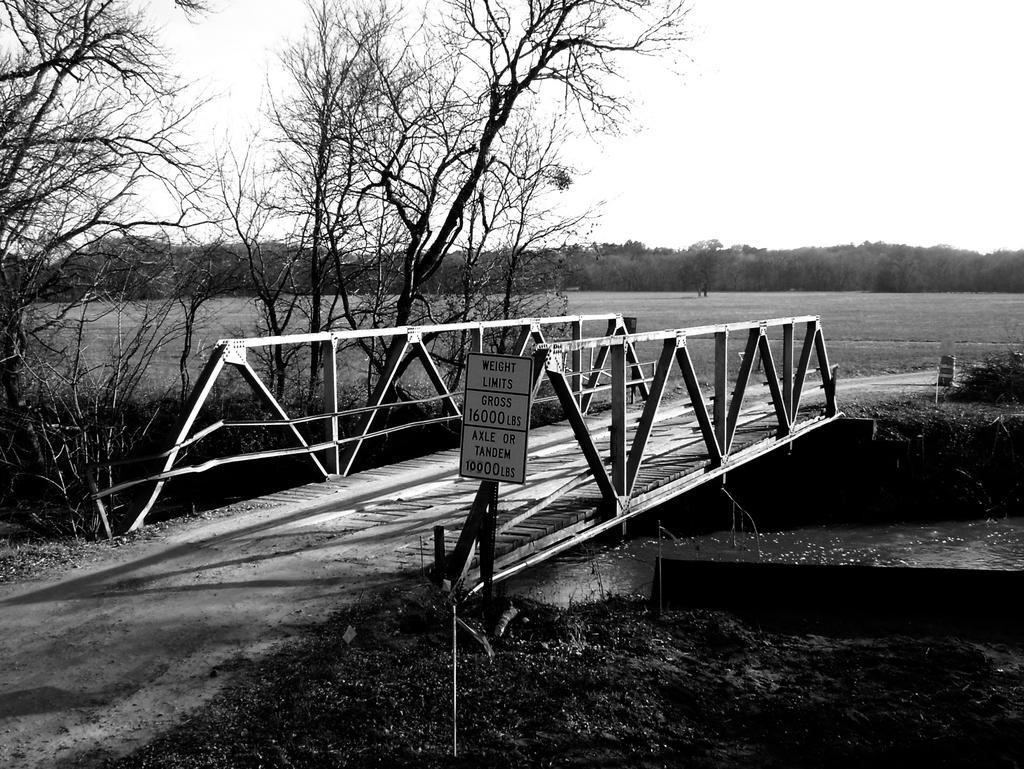How would you summarize this image in a sentence or two? In this picture I can see there is a wooden bridge and it has a precaution board and below the bridge there is a pond and there are trees, grass and the sky is clear. 